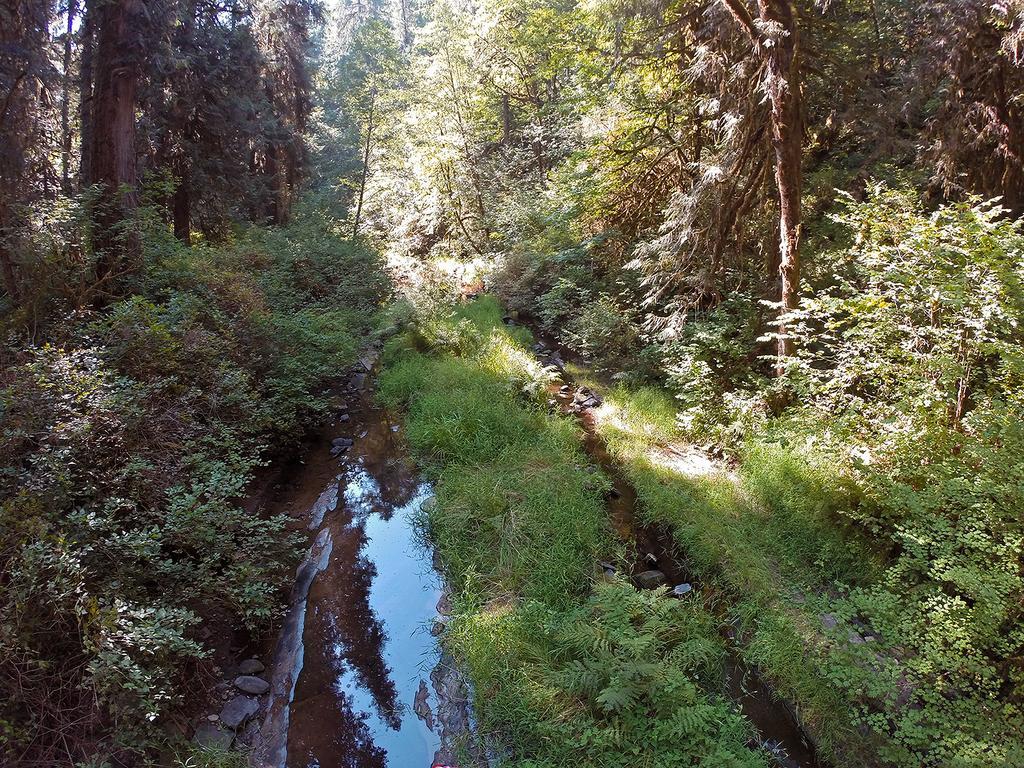Describe this image in one or two sentences. At the bottom of the image on the ground there is grass, water and also there are small plants. In the image there are many trees. 